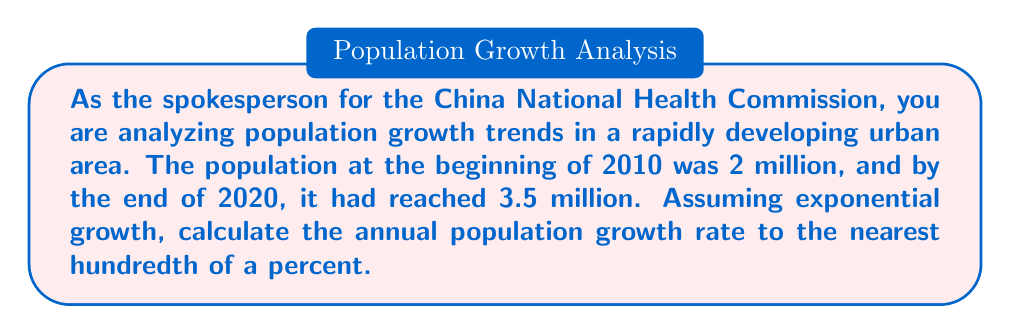Help me with this question. To solve this problem, we'll use the exponential growth model and logarithms. Let's break it down step-by-step:

1) The exponential growth model is given by:
   $$P(t) = P_0 e^{rt}$$
   where $P(t)$ is the population at time $t$, $P_0$ is the initial population, $r$ is the growth rate, and $t$ is the time in years.

2) We know:
   $P_0 = 2$ million (initial population in 2010)
   $P(10) = 3.5$ million (population after 10 years, in 2020)
   $t = 10$ years

3) Substituting these values into the equation:
   $$3.5 = 2e^{10r}$$

4) Divide both sides by 2:
   $$1.75 = e^{10r}$$

5) Take the natural logarithm of both sides:
   $$\ln(1.75) = \ln(e^{10r})$$

6) Using the logarithm property $\ln(e^x) = x$:
   $$\ln(1.75) = 10r$$

7) Solve for $r$:
   $$r = \frac{\ln(1.75)}{10}$$

8) Calculate $r$ using a calculator:
   $$r \approx 0.05596$$

9) Convert to a percentage by multiplying by 100:
   $$r \approx 5.596\%$$

10) Rounding to the nearest hundredth of a percent:
    $$r \approx 5.60\%$$
Answer: The annual population growth rate is approximately 5.60%. 